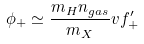<formula> <loc_0><loc_0><loc_500><loc_500>\phi _ { + } \simeq \frac { m _ { H } n _ { g a s } } { m _ { X } } v f _ { + } ^ { \prime }</formula> 